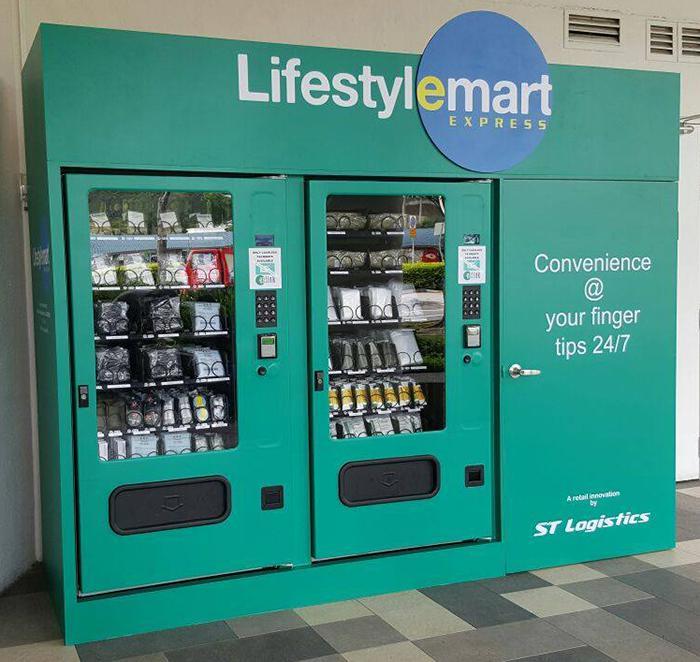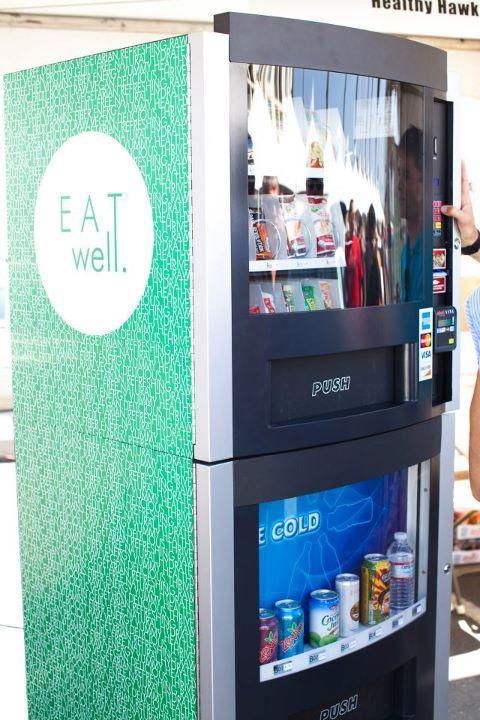The first image is the image on the left, the second image is the image on the right. Assess this claim about the two images: "The vending machine in the right image is predominately green.". Correct or not? Answer yes or no. Yes. The first image is the image on the left, the second image is the image on the right. For the images shown, is this caption "An image features a standalone vending machine with greenish sides that include a logo towards the top." true? Answer yes or no. Yes. 